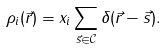Convert formula to latex. <formula><loc_0><loc_0><loc_500><loc_500>\rho _ { i } ( \vec { r } ) = x _ { i } \sum _ { \vec { s } \in \mathcal { C } } \delta ( \vec { r } - \vec { s } ) .</formula> 